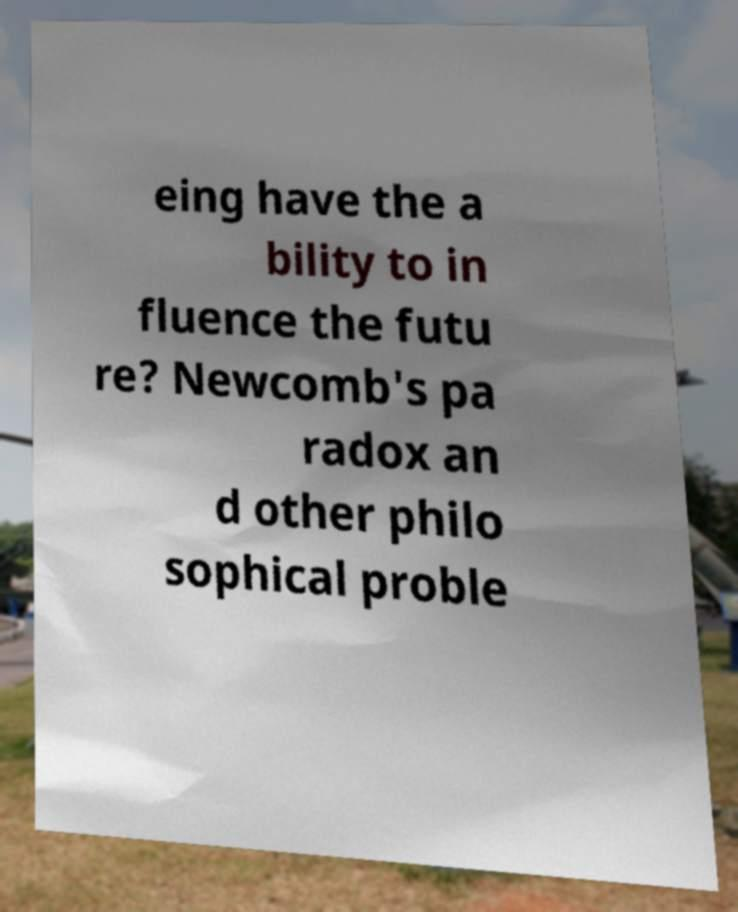Please read and relay the text visible in this image. What does it say? eing have the a bility to in fluence the futu re? Newcomb's pa radox an d other philo sophical proble 